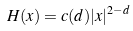Convert formula to latex. <formula><loc_0><loc_0><loc_500><loc_500>H ( x ) = c ( d ) | x | ^ { 2 - d }</formula> 